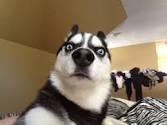What is in the picture, and what is it usually used to express? That is a picture of a dog. It is usually used to express shock or surprise. 